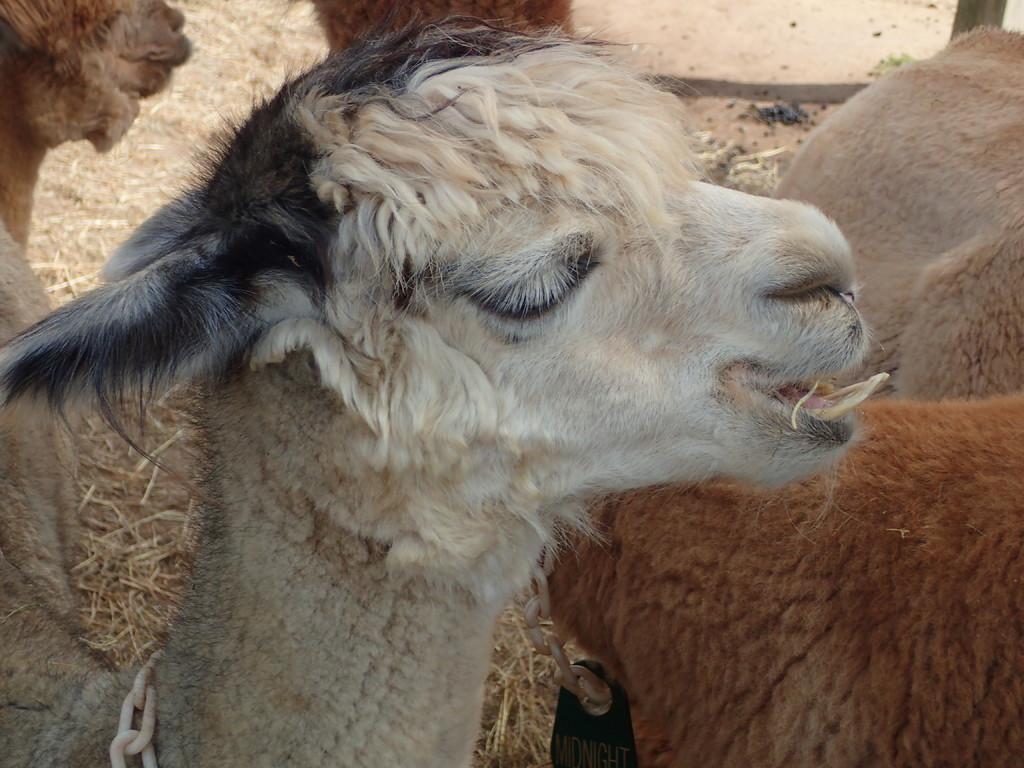Describe this image in one or two sentences. In the picture we can see a sheep which is white in color with some part black on its head and besides it we can see some sheep is brown in color. 